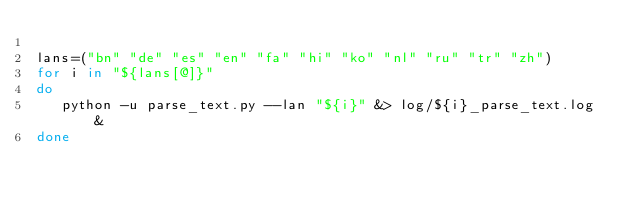<code> <loc_0><loc_0><loc_500><loc_500><_Bash_>
lans=("bn" "de" "es" "en" "fa" "hi" "ko" "nl" "ru" "tr" "zh")
for i in "${lans[@]}"
do
   python -u parse_text.py --lan "${i}" &> log/${i}_parse_text.log &
done

</code> 